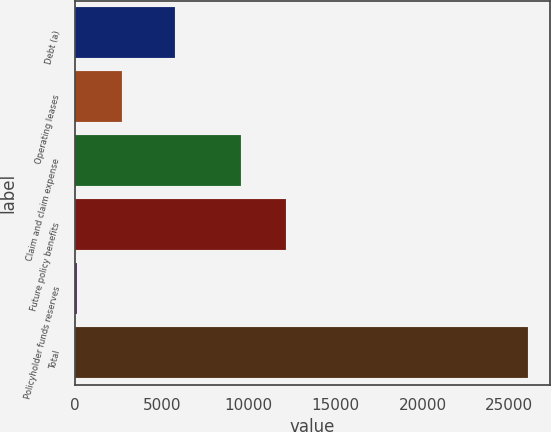Convert chart. <chart><loc_0><loc_0><loc_500><loc_500><bar_chart><fcel>Debt (a)<fcel>Operating leases<fcel>Claim and claim expense<fcel>Future policy benefits<fcel>Policyholder funds reserves<fcel>Total<nl><fcel>5743<fcel>2696.9<fcel>9565<fcel>12160.9<fcel>101<fcel>26060<nl></chart> 